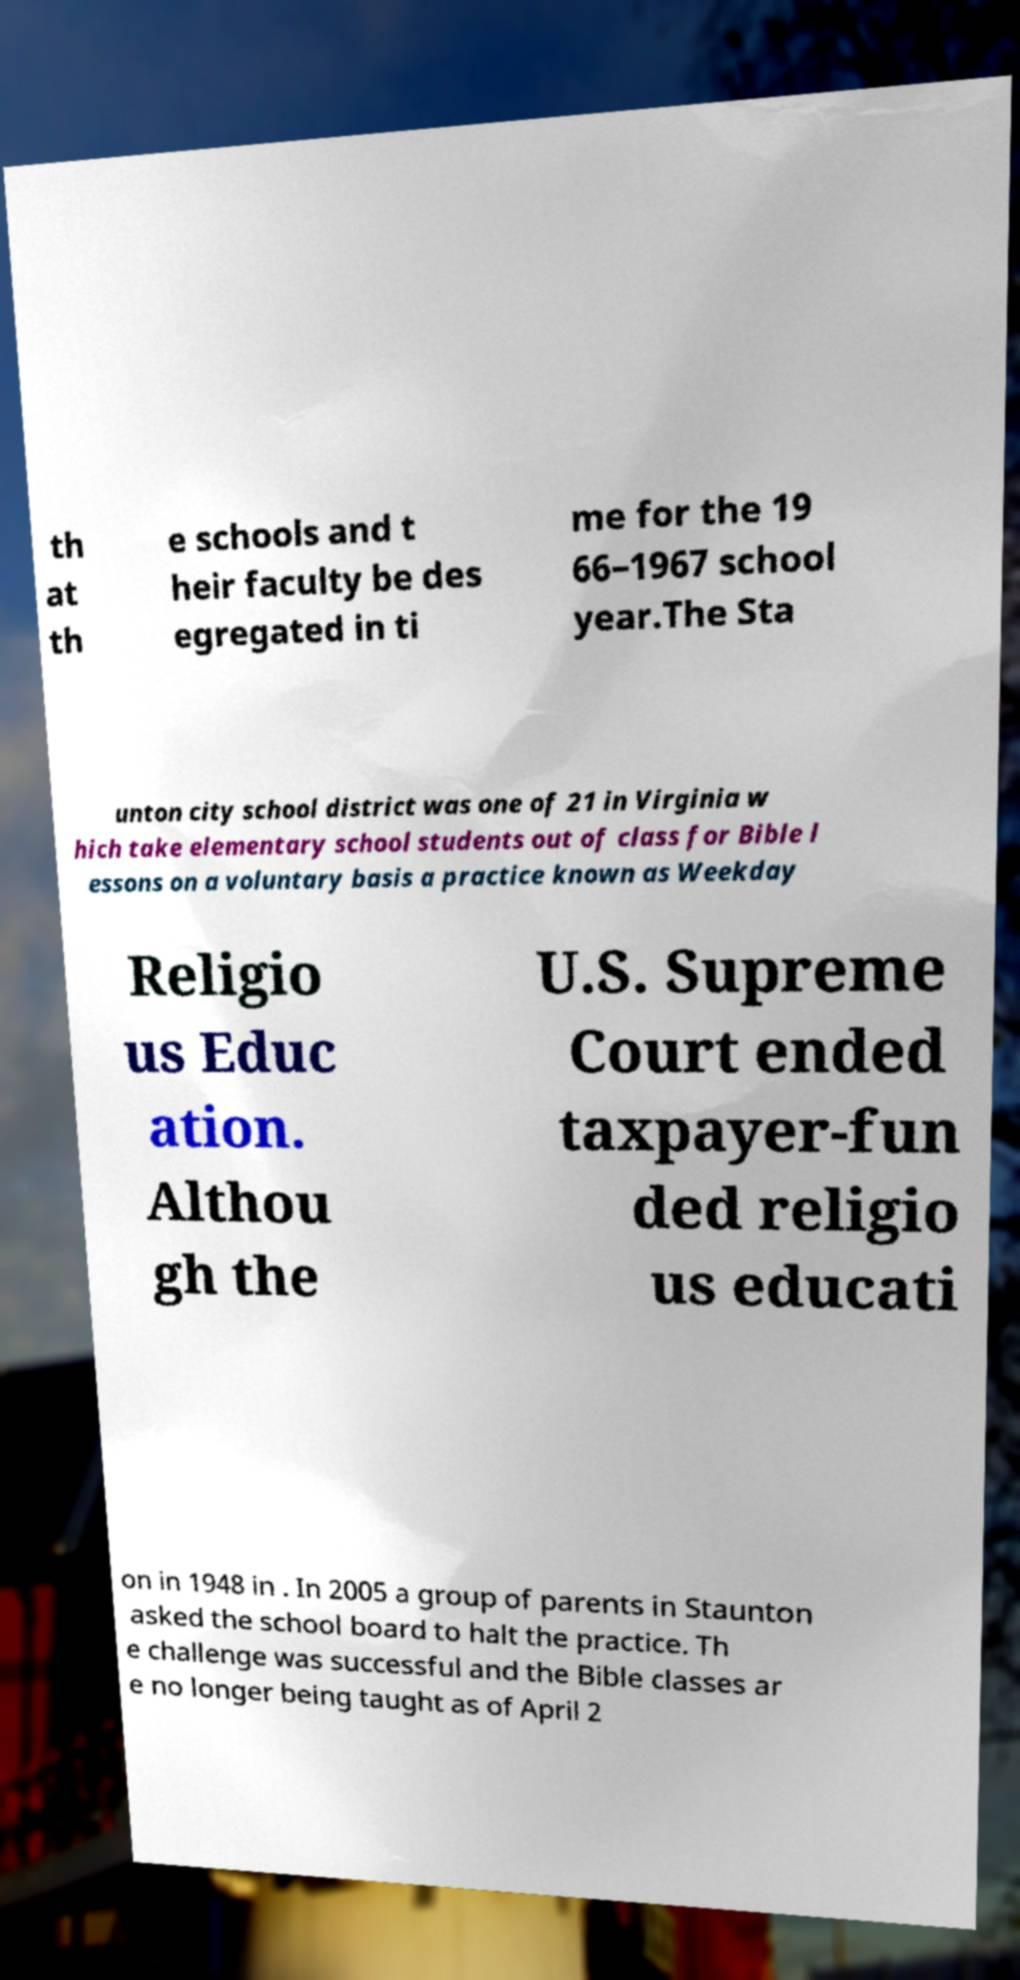For documentation purposes, I need the text within this image transcribed. Could you provide that? th at th e schools and t heir faculty be des egregated in ti me for the 19 66–1967 school year.The Sta unton city school district was one of 21 in Virginia w hich take elementary school students out of class for Bible l essons on a voluntary basis a practice known as Weekday Religio us Educ ation. Althou gh the U.S. Supreme Court ended taxpayer-fun ded religio us educati on in 1948 in . In 2005 a group of parents in Staunton asked the school board to halt the practice. Th e challenge was successful and the Bible classes ar e no longer being taught as of April 2 